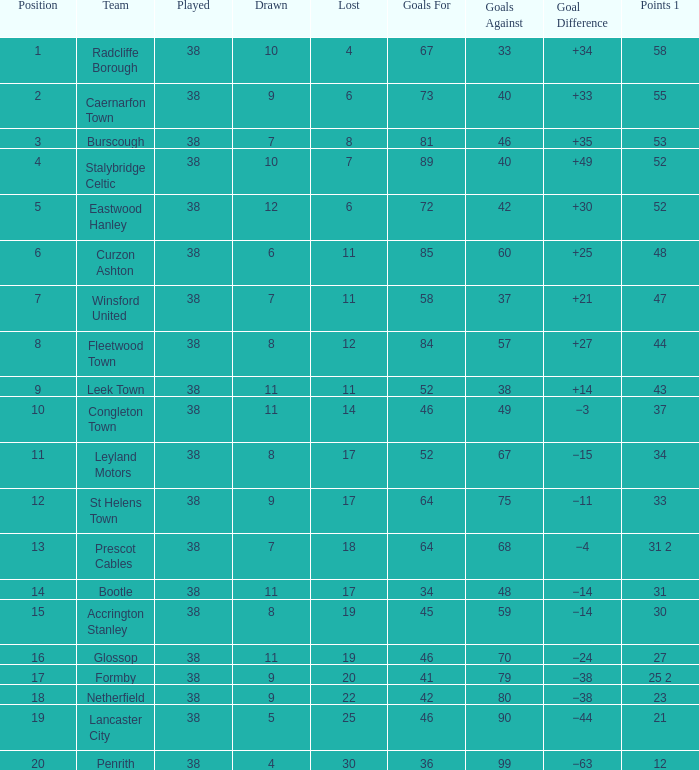What is the total played with points 1 of 53, and location greater than 3? None. 